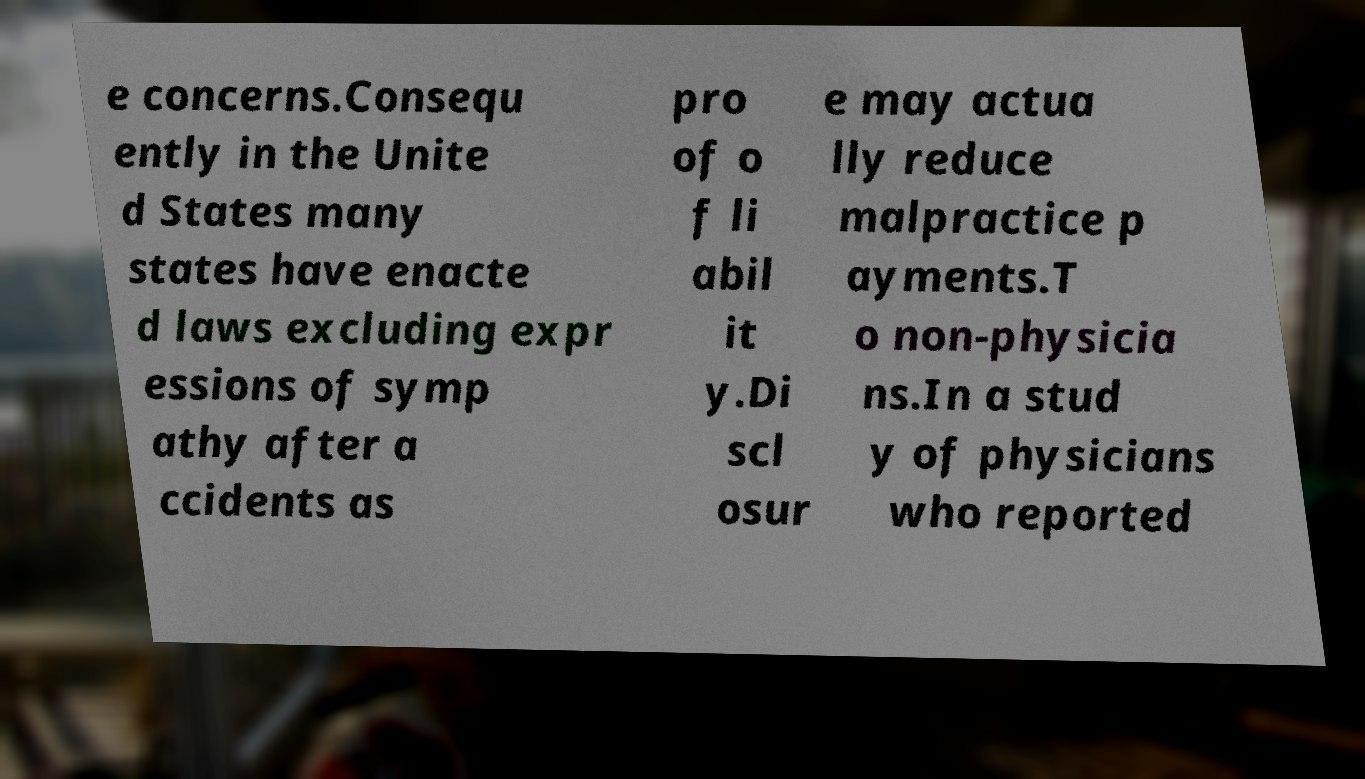Please identify and transcribe the text found in this image. e concerns.Consequ ently in the Unite d States many states have enacte d laws excluding expr essions of symp athy after a ccidents as pro of o f li abil it y.Di scl osur e may actua lly reduce malpractice p ayments.T o non-physicia ns.In a stud y of physicians who reported 